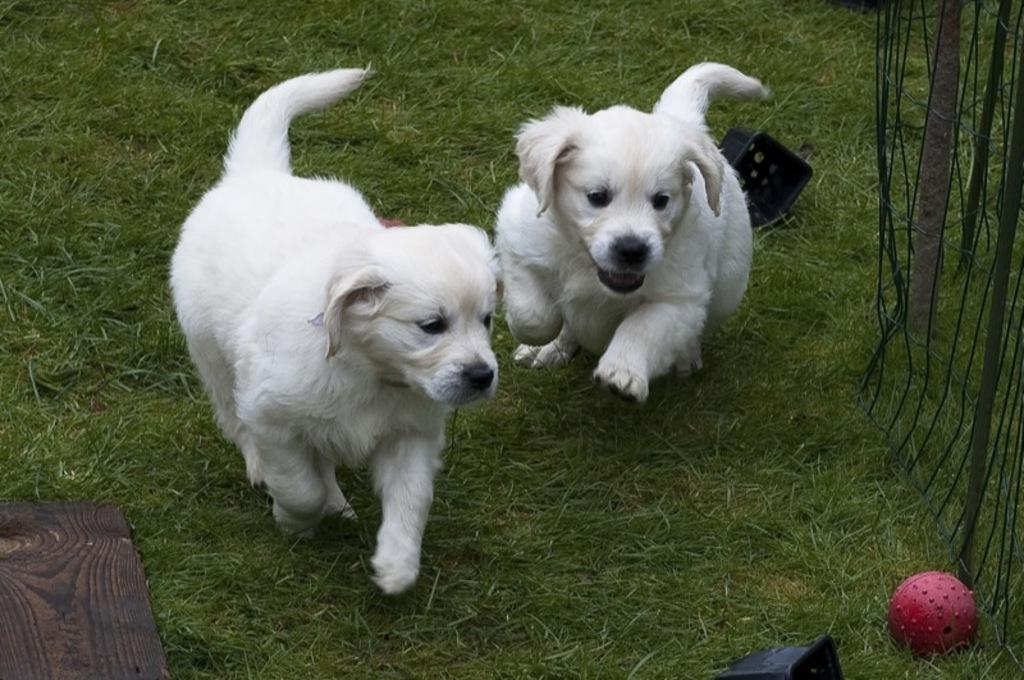Could you give a brief overview of what you see in this image? In the picture there is ground, there are two puppies playing with a ball. 